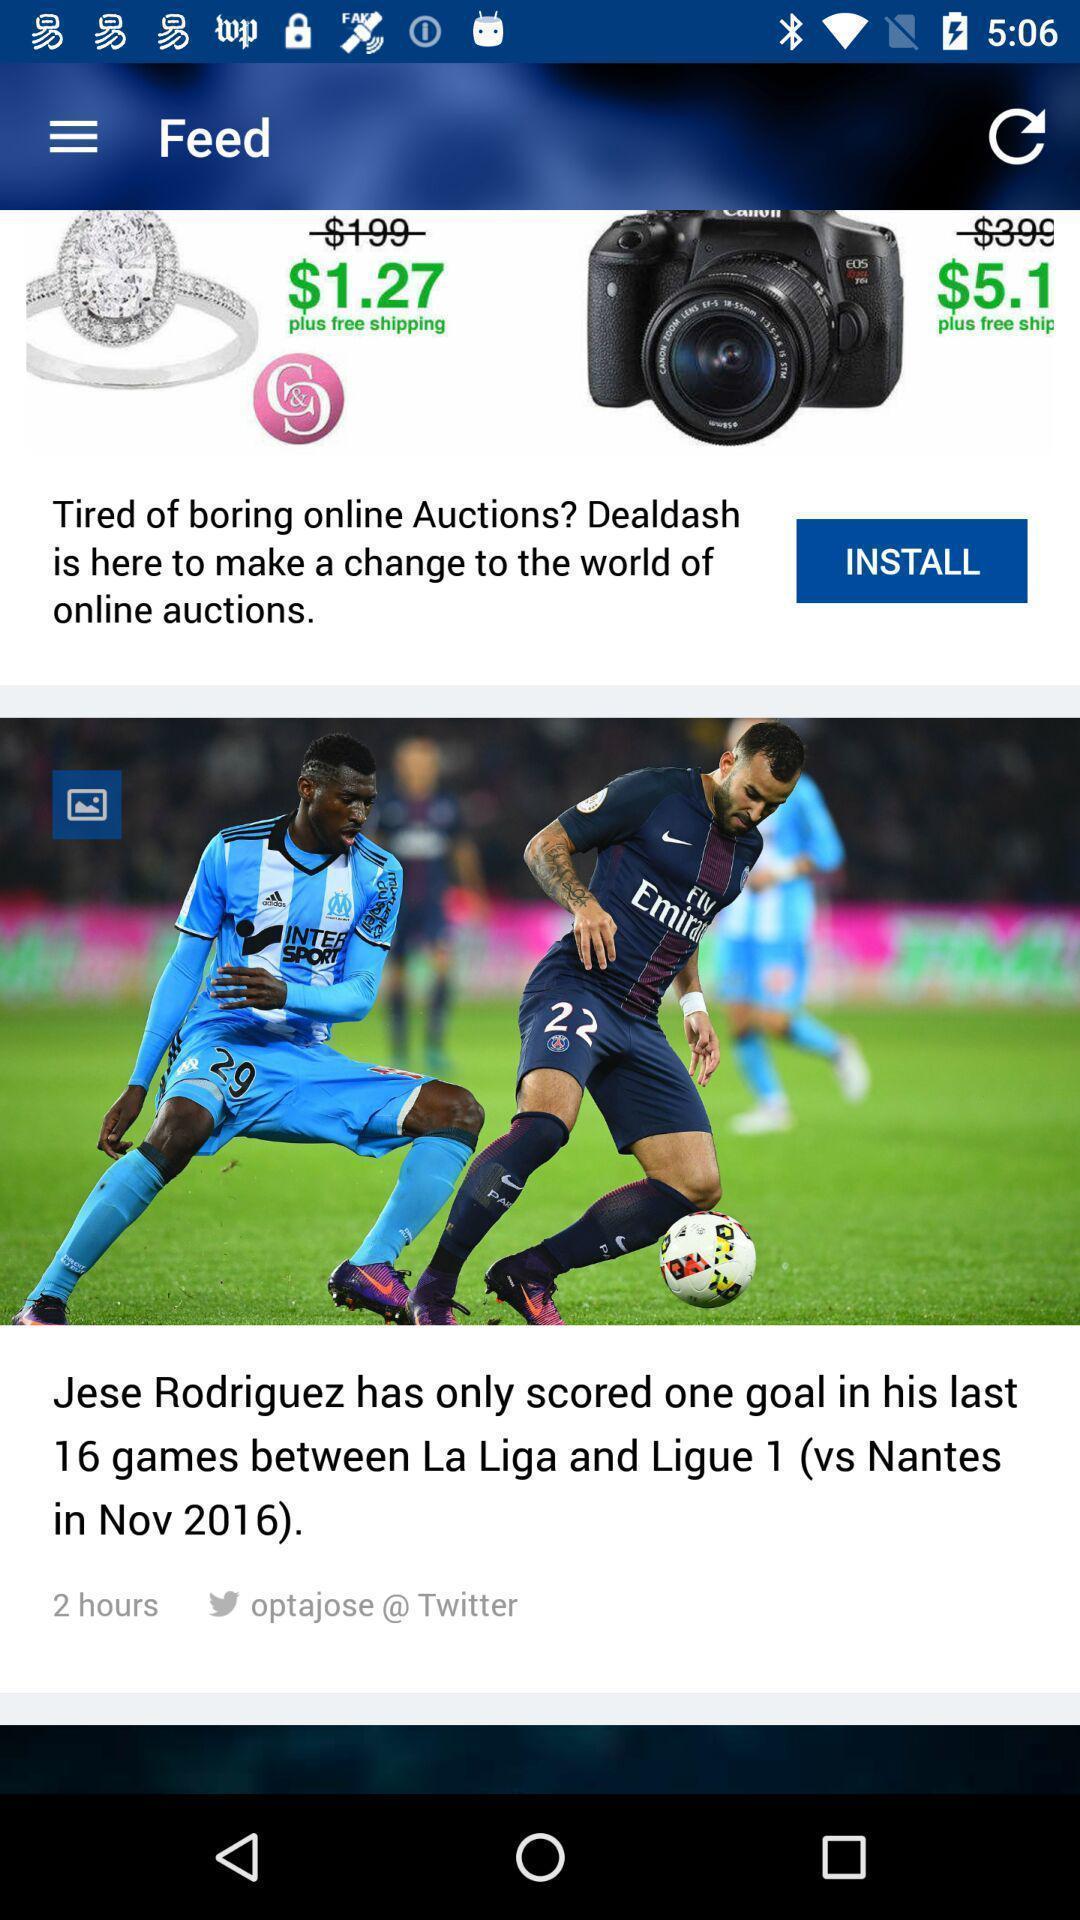Explain what's happening in this screen capture. Page displays sports news in app. 